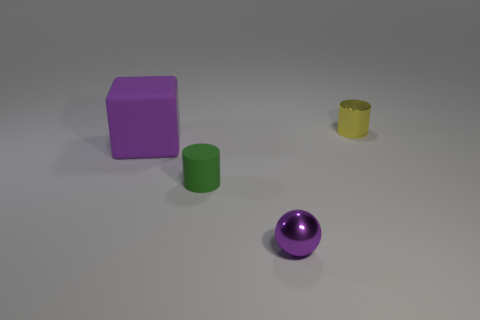Imagine this is an educational image. What could it be teaching? This image could serve as an educational tool in various ways. For example, it could be used to teach basic geometry and colors to young children, illustrating shapes like cubes, spheres, and cylinders. For older students, it could be part of a lesson on computer graphics, demonstrating the rendering of different materials and the effects of lighting and shadow. It could also be used in a physics lesson about optics to explain how light interacts with objects of different colors and materials. 